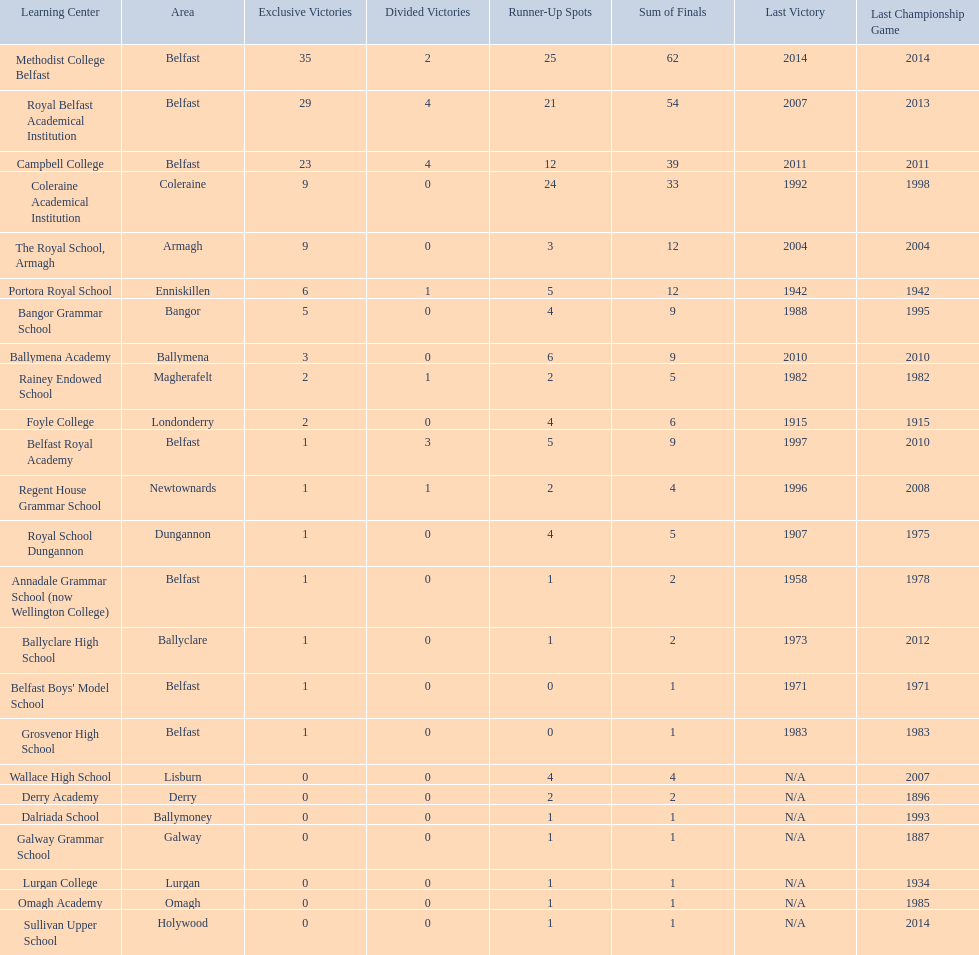How many outright titles does coleraine academical institution have? 9. What other school has this amount of outright titles The Royal School, Armagh. 